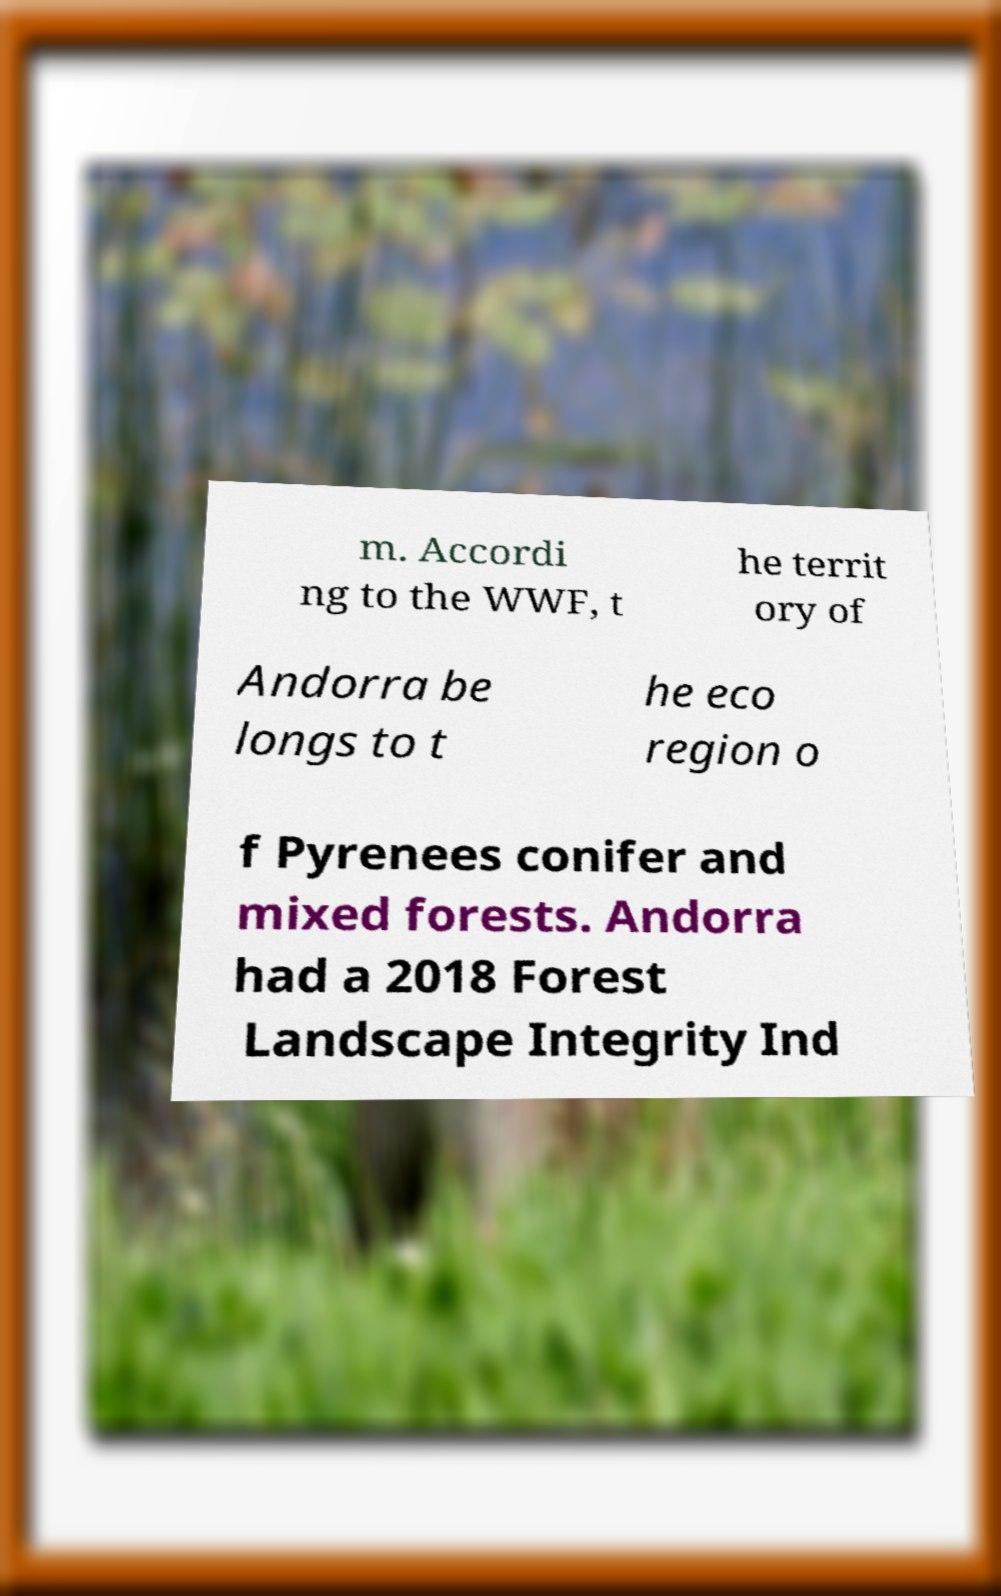Can you accurately transcribe the text from the provided image for me? m. Accordi ng to the WWF, t he territ ory of Andorra be longs to t he eco region o f Pyrenees conifer and mixed forests. Andorra had a 2018 Forest Landscape Integrity Ind 